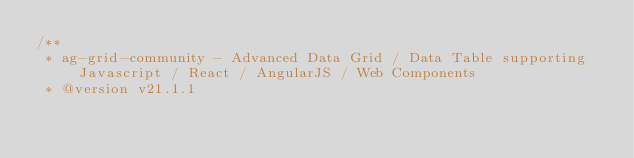Convert code to text. <code><loc_0><loc_0><loc_500><loc_500><_JavaScript_>/**
 * ag-grid-community - Advanced Data Grid / Data Table supporting Javascript / React / AngularJS / Web Components
 * @version v21.1.1</code> 